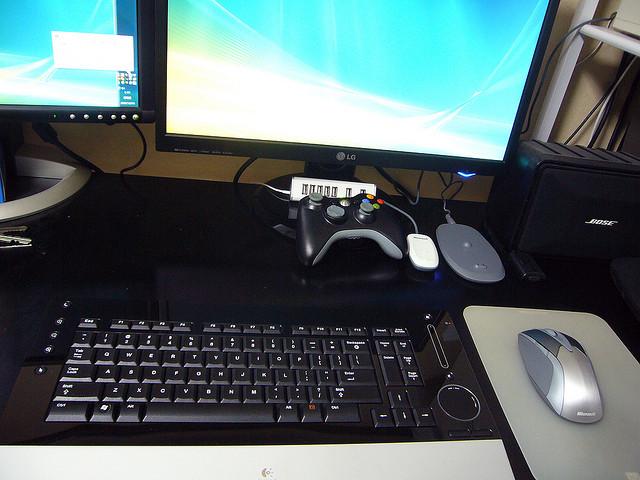What is to the right of the keyboard?
Concise answer only. Mouse. What brand is this computer?
Concise answer only. Lg. How many monitors are there?
Answer briefly. 2. Do the images on the monitor match completely?
Answer briefly. No. 